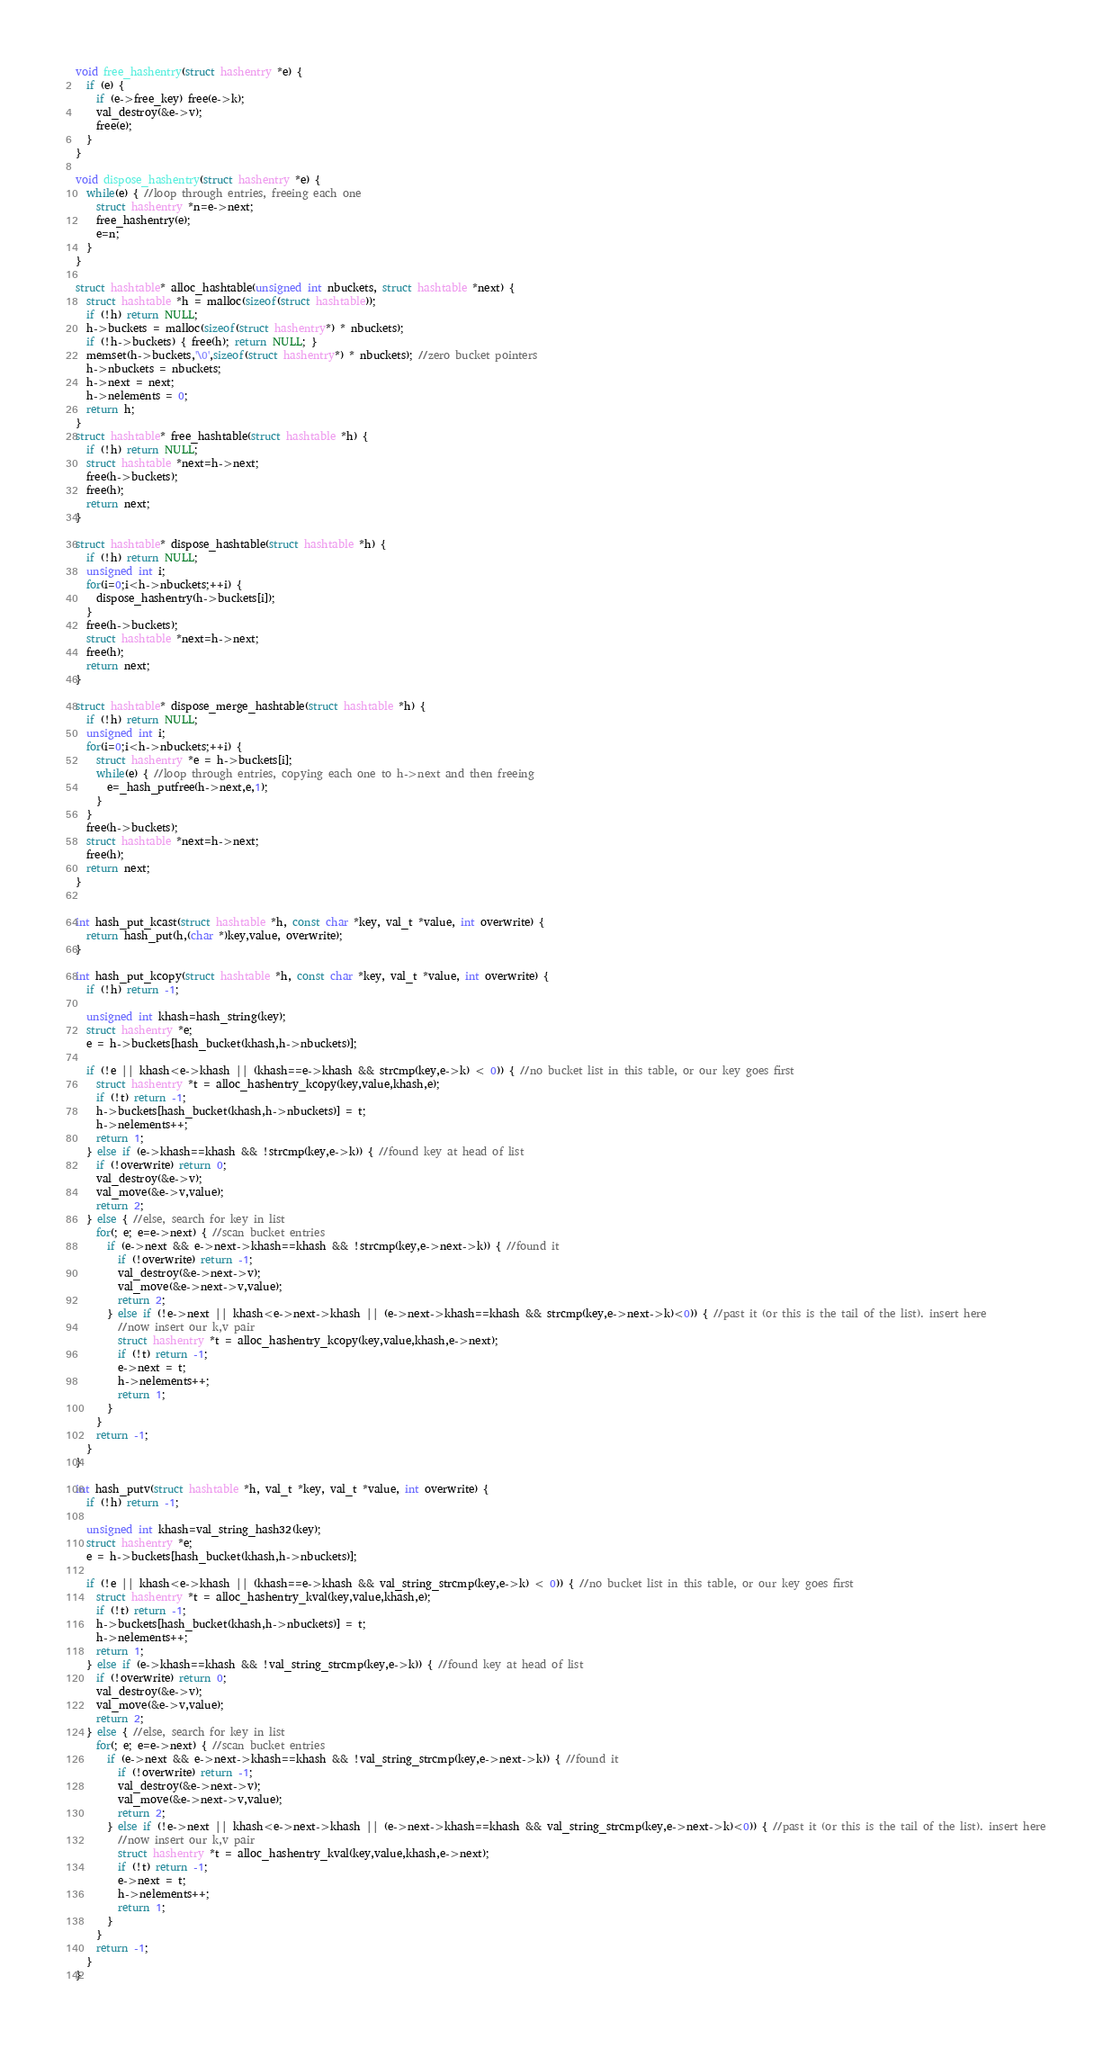Convert code to text. <code><loc_0><loc_0><loc_500><loc_500><_C_>
void free_hashentry(struct hashentry *e) {
  if (e) {
    if (e->free_key) free(e->k);
    val_destroy(&e->v);
    free(e);
  }
}

void dispose_hashentry(struct hashentry *e) {
  while(e) { //loop through entries, freeing each one
    struct hashentry *n=e->next;
    free_hashentry(e);
    e=n;
  }
}

struct hashtable* alloc_hashtable(unsigned int nbuckets, struct hashtable *next) {
  struct hashtable *h = malloc(sizeof(struct hashtable));
  if (!h) return NULL;
  h->buckets = malloc(sizeof(struct hashentry*) * nbuckets);
  if (!h->buckets) { free(h); return NULL; }
  memset(h->buckets,'\0',sizeof(struct hashentry*) * nbuckets); //zero bucket pointers
  h->nbuckets = nbuckets;
  h->next = next;
  h->nelements = 0;
  return h;
}
struct hashtable* free_hashtable(struct hashtable *h) {
  if (!h) return NULL;
  struct hashtable *next=h->next;
  free(h->buckets);
  free(h);
  return next;
}

struct hashtable* dispose_hashtable(struct hashtable *h) {
  if (!h) return NULL;
  unsigned int i;
  for(i=0;i<h->nbuckets;++i) {
    dispose_hashentry(h->buckets[i]);
  }
  free(h->buckets);
  struct hashtable *next=h->next;
  free(h);
  return next;
}

struct hashtable* dispose_merge_hashtable(struct hashtable *h) {
  if (!h) return NULL;
  unsigned int i;
  for(i=0;i<h->nbuckets;++i) {
    struct hashentry *e = h->buckets[i];
    while(e) { //loop through entries, copying each one to h->next and then freeing
      e=_hash_putfree(h->next,e,1);
    }
  }
  free(h->buckets);
  struct hashtable *next=h->next;
  free(h);
  return next;
}


int hash_put_kcast(struct hashtable *h, const char *key, val_t *value, int overwrite) {
  return hash_put(h,(char *)key,value, overwrite);
}

int hash_put_kcopy(struct hashtable *h, const char *key, val_t *value, int overwrite) {
  if (!h) return -1;

  unsigned int khash=hash_string(key);
  struct hashentry *e;
  e = h->buckets[hash_bucket(khash,h->nbuckets)];

  if (!e || khash<e->khash || (khash==e->khash && strcmp(key,e->k) < 0)) { //no bucket list in this table, or our key goes first
    struct hashentry *t = alloc_hashentry_kcopy(key,value,khash,e);
    if (!t) return -1;
    h->buckets[hash_bucket(khash,h->nbuckets)] = t;
    h->nelements++;
    return 1;
  } else if (e->khash==khash && !strcmp(key,e->k)) { //found key at head of list
    if (!overwrite) return 0;
    val_destroy(&e->v);
    val_move(&e->v,value);
    return 2;
  } else { //else, search for key in list
    for(; e; e=e->next) { //scan bucket entries
      if (e->next && e->next->khash==khash && !strcmp(key,e->next->k)) { //found it
        if (!overwrite) return -1;
        val_destroy(&e->next->v);
        val_move(&e->next->v,value);
        return 2;
      } else if (!e->next || khash<e->next->khash || (e->next->khash==khash && strcmp(key,e->next->k)<0)) { //past it (or this is the tail of the list). insert here
        //now insert our k,v pair
        struct hashentry *t = alloc_hashentry_kcopy(key,value,khash,e->next);
        if (!t) return -1;
        e->next = t;
        h->nelements++;
        return 1;
      }
    }
    return -1;
  }
}

int hash_putv(struct hashtable *h, val_t *key, val_t *value, int overwrite) {
  if (!h) return -1;

  unsigned int khash=val_string_hash32(key);
  struct hashentry *e;
  e = h->buckets[hash_bucket(khash,h->nbuckets)];

  if (!e || khash<e->khash || (khash==e->khash && val_string_strcmp(key,e->k) < 0)) { //no bucket list in this table, or our key goes first
    struct hashentry *t = alloc_hashentry_kval(key,value,khash,e);
    if (!t) return -1;
    h->buckets[hash_bucket(khash,h->nbuckets)] = t;
    h->nelements++;
    return 1;
  } else if (e->khash==khash && !val_string_strcmp(key,e->k)) { //found key at head of list
    if (!overwrite) return 0;
    val_destroy(&e->v);
    val_move(&e->v,value);
    return 2;
  } else { //else, search for key in list
    for(; e; e=e->next) { //scan bucket entries
      if (e->next && e->next->khash==khash && !val_string_strcmp(key,e->next->k)) { //found it
        if (!overwrite) return -1;
        val_destroy(&e->next->v);
        val_move(&e->next->v,value);
        return 2;
      } else if (!e->next || khash<e->next->khash || (e->next->khash==khash && val_string_strcmp(key,e->next->k)<0)) { //past it (or this is the tail of the list). insert here
        //now insert our k,v pair
        struct hashentry *t = alloc_hashentry_kval(key,value,khash,e->next);
        if (!t) return -1;
        e->next = t;
        h->nelements++;
        return 1;
      }
    }
    return -1;
  }
}
</code> 